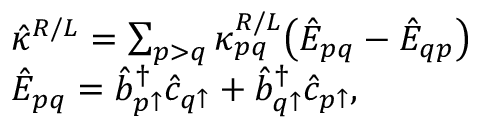<formula> <loc_0><loc_0><loc_500><loc_500>\begin{array} { r l } & { \hat { \kappa } ^ { R / L } = \sum _ { p > q } \kappa _ { p q } ^ { R / L } \left ( \hat { E } _ { p q } - \hat { E } _ { q p } \right ) } \\ & { \hat { E } _ { p q } = \hat { b } _ { p \uparrow } ^ { \dagger } \hat { c } _ { q \uparrow } + \hat { b } _ { q \uparrow } ^ { \dagger } \hat { c } _ { p \uparrow } , } \end{array}</formula> 